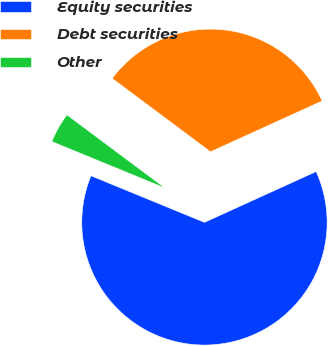<chart> <loc_0><loc_0><loc_500><loc_500><pie_chart><fcel>Equity securities<fcel>Debt securities<fcel>Other<nl><fcel>63.0%<fcel>33.0%<fcel>4.0%<nl></chart> 